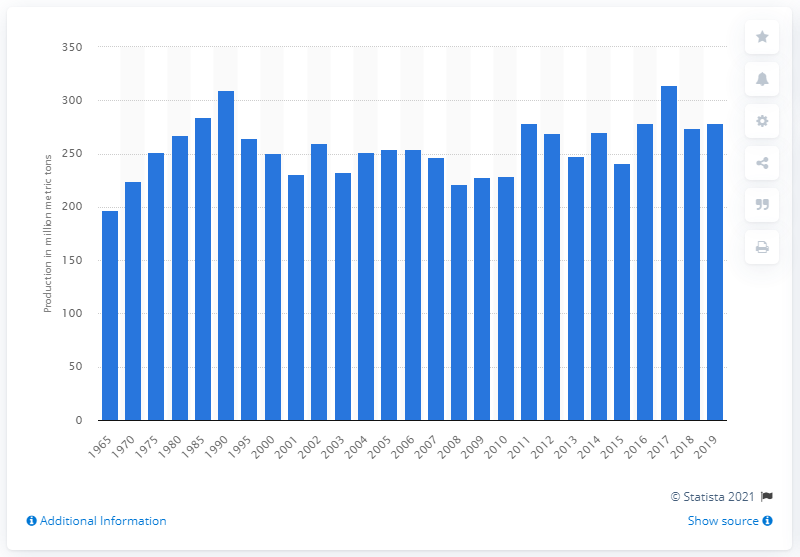How much sugar beet was produced worldwide in 2019? In 2019, global sugar beet production reached approximately 300 million metric tons, demonstrating a steady increase over the past few years with some fluctuations. This figure emphasizes the importance of sugar beet as a crop in producing sugar and related products. 